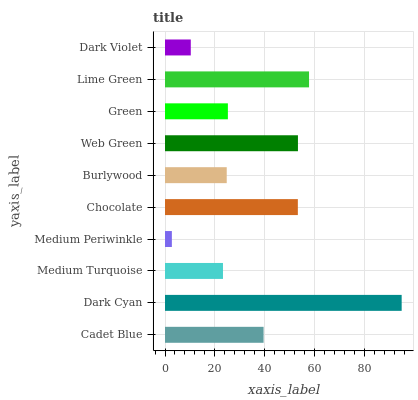Is Medium Periwinkle the minimum?
Answer yes or no. Yes. Is Dark Cyan the maximum?
Answer yes or no. Yes. Is Medium Turquoise the minimum?
Answer yes or no. No. Is Medium Turquoise the maximum?
Answer yes or no. No. Is Dark Cyan greater than Medium Turquoise?
Answer yes or no. Yes. Is Medium Turquoise less than Dark Cyan?
Answer yes or no. Yes. Is Medium Turquoise greater than Dark Cyan?
Answer yes or no. No. Is Dark Cyan less than Medium Turquoise?
Answer yes or no. No. Is Cadet Blue the high median?
Answer yes or no. Yes. Is Green the low median?
Answer yes or no. Yes. Is Green the high median?
Answer yes or no. No. Is Burlywood the low median?
Answer yes or no. No. 